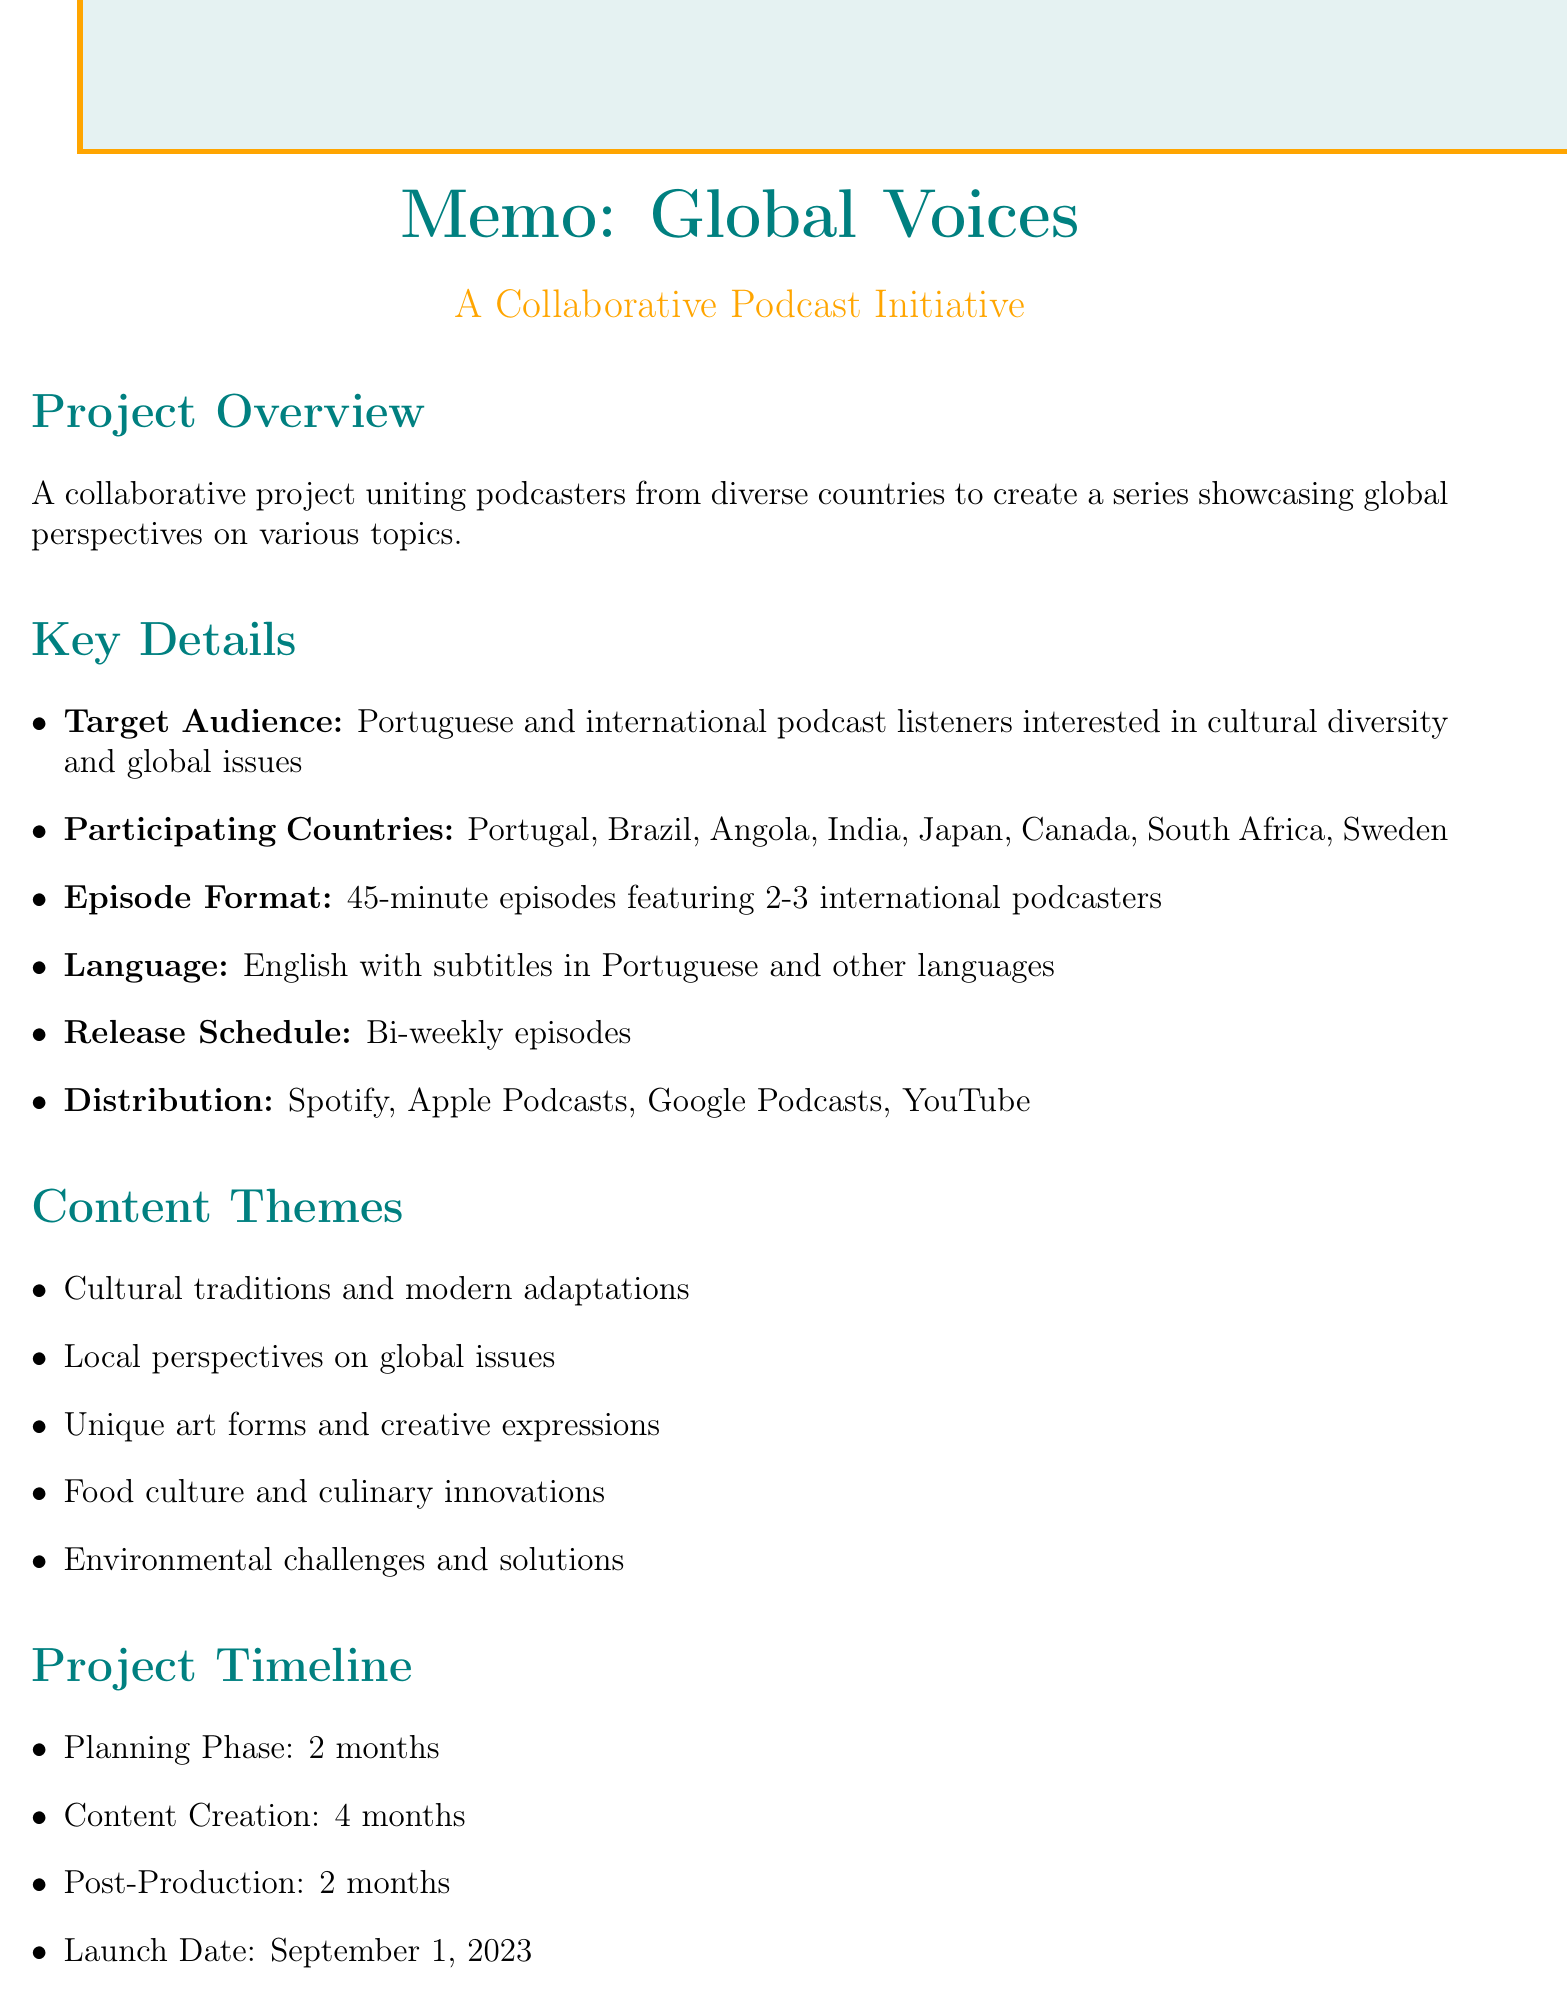What is the project title? The project title is mentioned in the header of the memo.
Answer: Global Voices: A Collaborative Podcast Initiative What is the launch date? The launch date is listed under the project timeline section.
Answer: September 1, 2023 What is the budget for marketing? The budget for marketing is included in the budget considerations section.
Answer: €10,000 Which countries are participating? The participating countries are enumerated in a list format in the memo.
Answer: Portugal, Brazil, Angola, India, Japan, Canada, South Africa, Sweden How long is each episode? The episode format section specifies the duration of the episodes.
Answer: 45 minutes What is the primary language of the podcast? The language of the podcast is mentioned under the production details.
Answer: English What are two content themes? The content themes are listed in the relevant section, and two can be chosen from that list.
Answer: Cultural traditions and modern adaptations, Local perspectives on global issues Who is the local promotion partner? The key partners section identifies the local promotion partner.
Answer: Radio Comercial How many episodes are expected to be created? The expected outcomes section mentions the number of episodes anticipated.
Answer: 12 episodes What is one potential challenge mentioned? Potential challenges are listed, and one can be selected from that list.
Answer: Coordinating across multiple time zones 